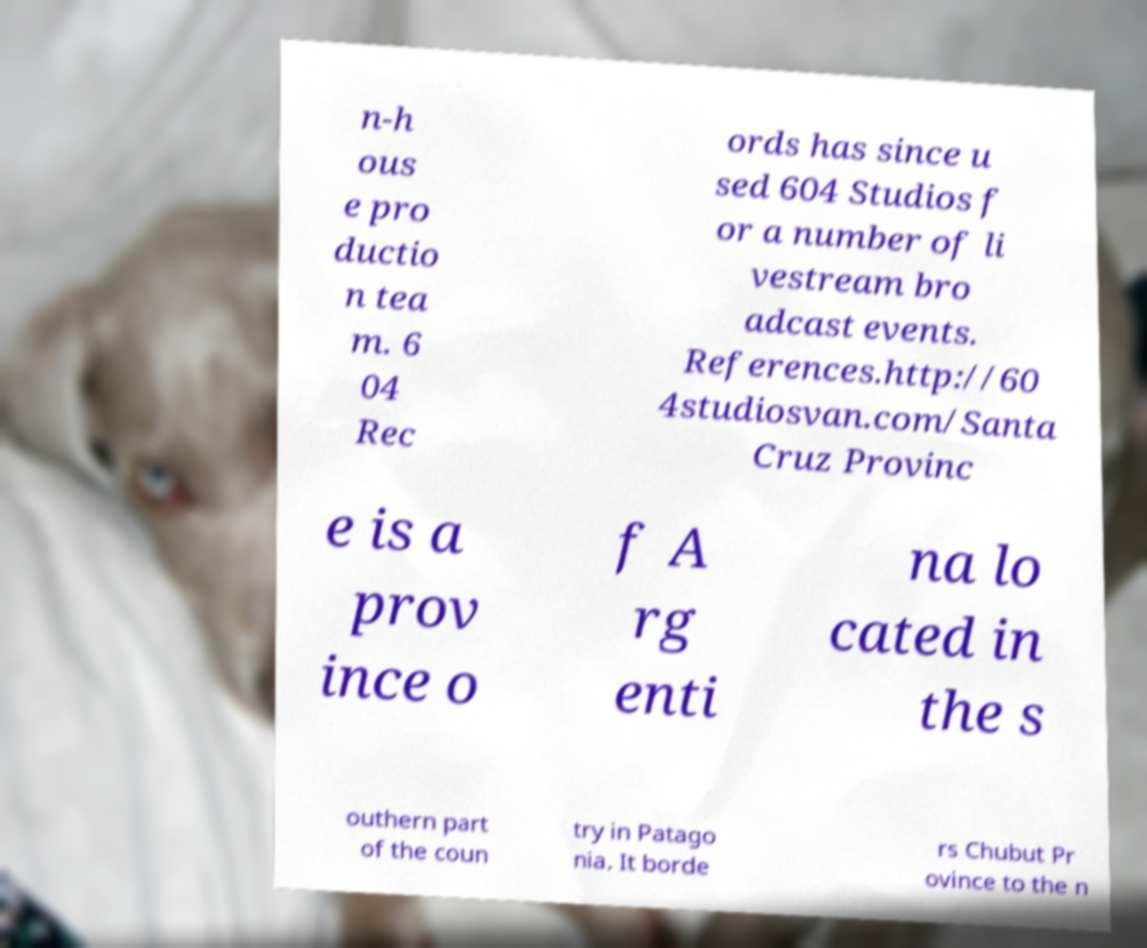For documentation purposes, I need the text within this image transcribed. Could you provide that? n-h ous e pro ductio n tea m. 6 04 Rec ords has since u sed 604 Studios f or a number of li vestream bro adcast events. References.http://60 4studiosvan.com/Santa Cruz Provinc e is a prov ince o f A rg enti na lo cated in the s outhern part of the coun try in Patago nia. It borde rs Chubut Pr ovince to the n 